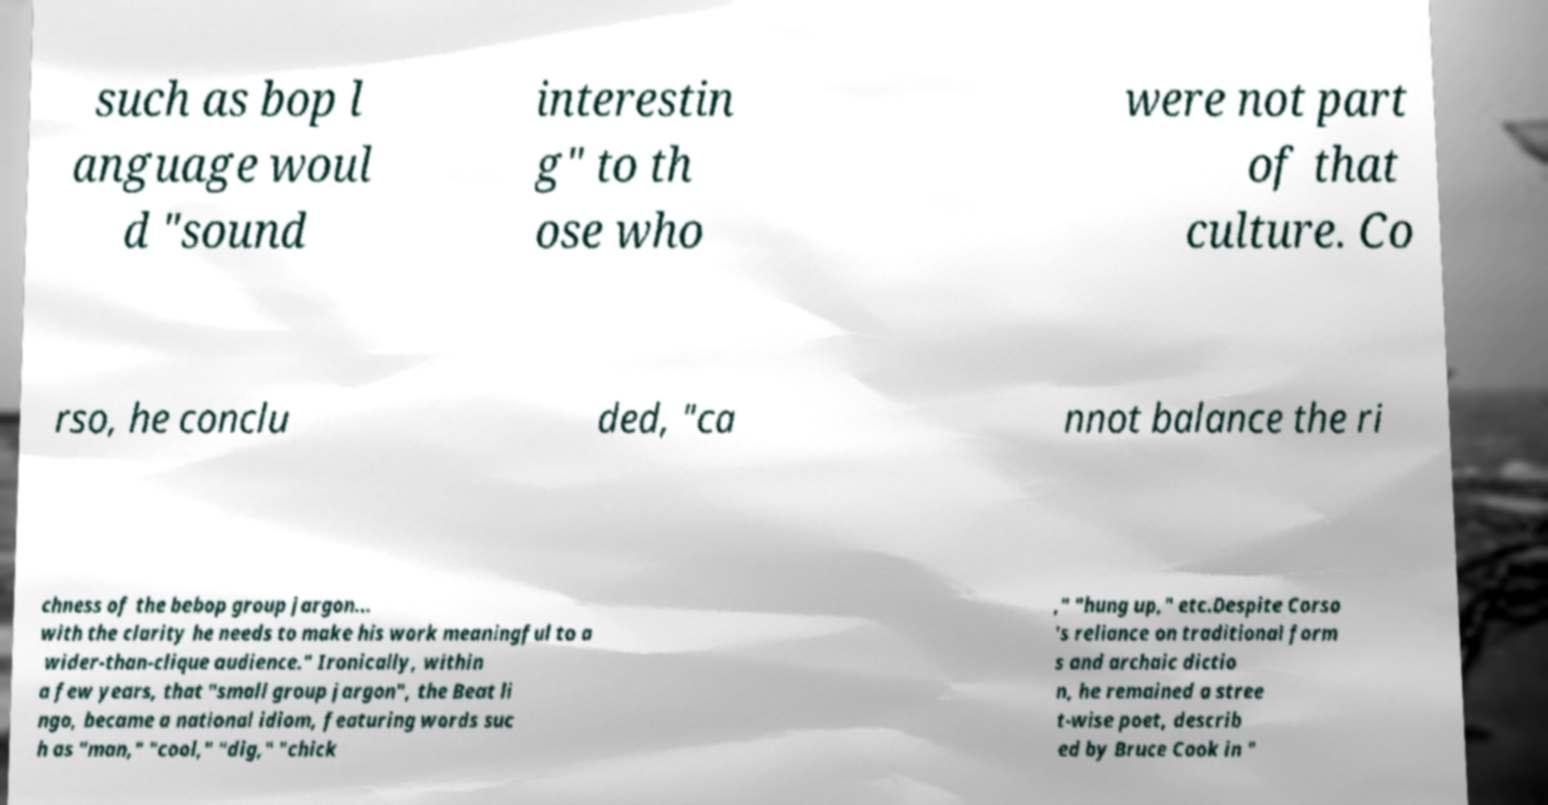For documentation purposes, I need the text within this image transcribed. Could you provide that? such as bop l anguage woul d "sound interestin g" to th ose who were not part of that culture. Co rso, he conclu ded, "ca nnot balance the ri chness of the bebop group jargon... with the clarity he needs to make his work meaningful to a wider-than-clique audience." Ironically, within a few years, that "small group jargon", the Beat li ngo, became a national idiom, featuring words suc h as "man," "cool," "dig," "chick ," "hung up," etc.Despite Corso 's reliance on traditional form s and archaic dictio n, he remained a stree t-wise poet, describ ed by Bruce Cook in " 